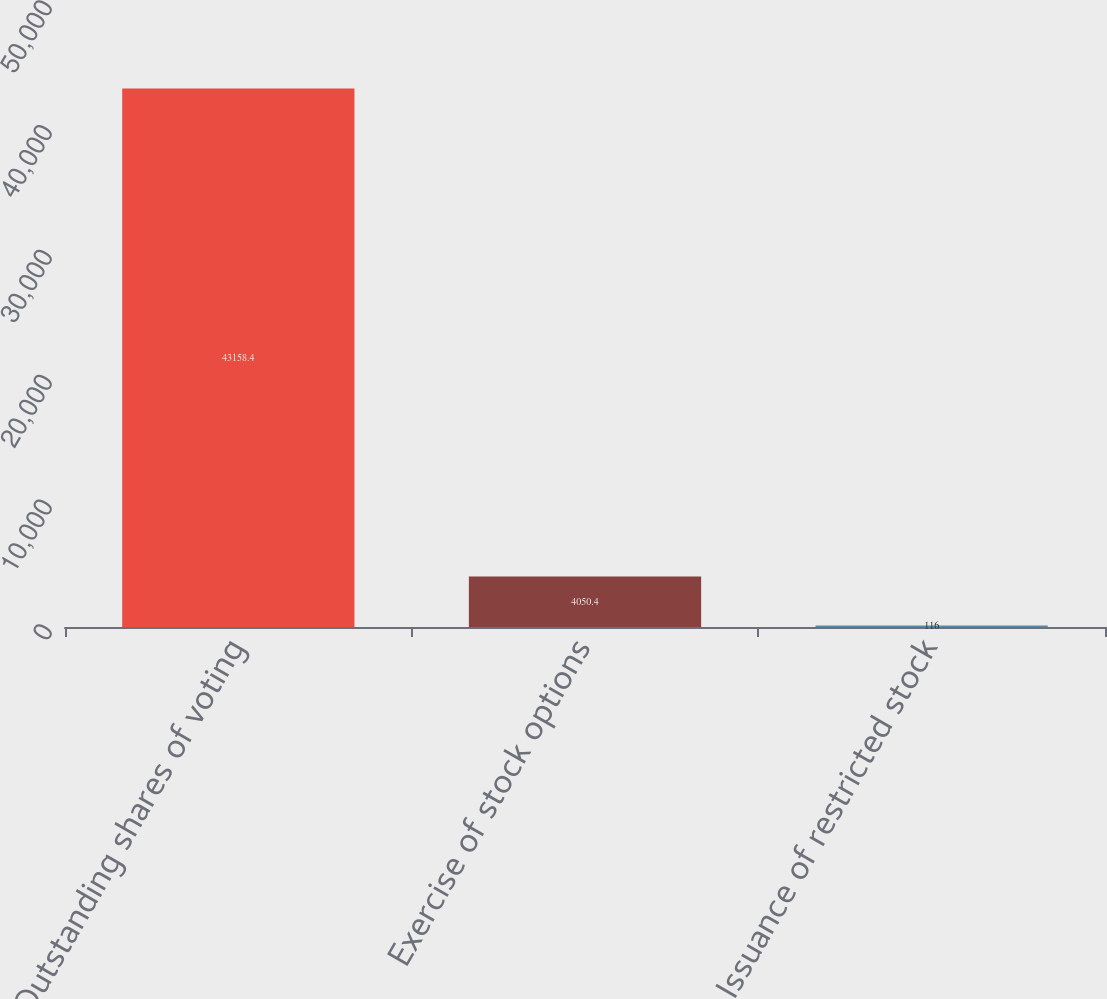Convert chart to OTSL. <chart><loc_0><loc_0><loc_500><loc_500><bar_chart><fcel>Outstanding shares of voting<fcel>Exercise of stock options<fcel>Issuance of restricted stock<nl><fcel>43158.4<fcel>4050.4<fcel>116<nl></chart> 